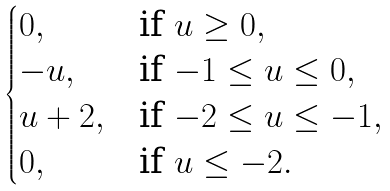Convert formula to latex. <formula><loc_0><loc_0><loc_500><loc_500>\begin{cases} 0 , & \text {if $u \geq 0$} , \\ - u , & \text {if $-1 \leq u \leq 0$} , \\ u + 2 , & \text {if $-2 \leq u \leq -1$} , \\ 0 , & \text {if $u \leq -2$} . \end{cases}</formula> 